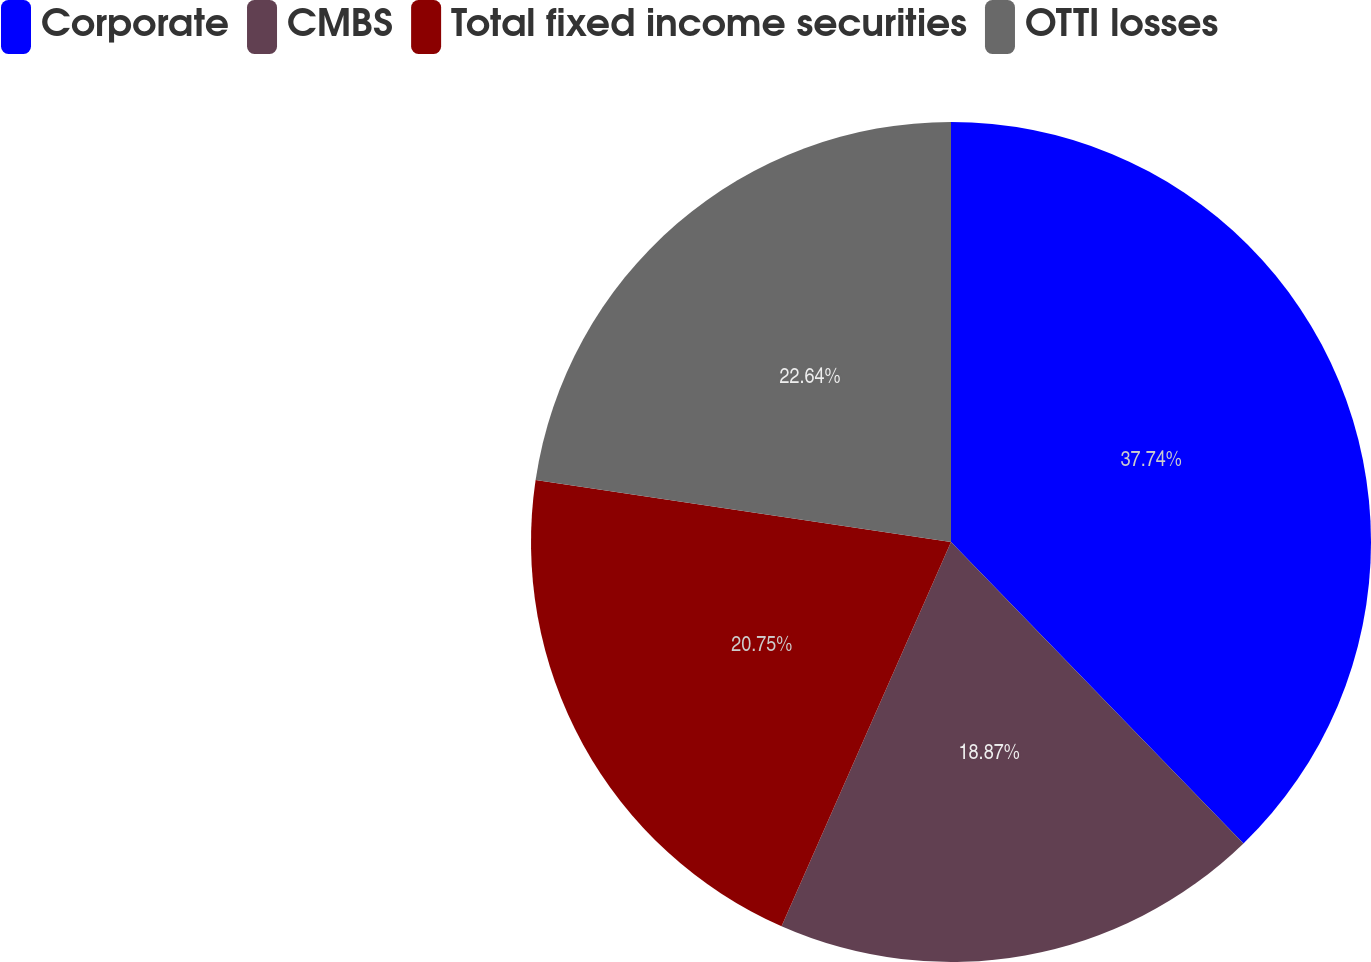Convert chart to OTSL. <chart><loc_0><loc_0><loc_500><loc_500><pie_chart><fcel>Corporate<fcel>CMBS<fcel>Total fixed income securities<fcel>OTTI losses<nl><fcel>37.74%<fcel>18.87%<fcel>20.75%<fcel>22.64%<nl></chart> 